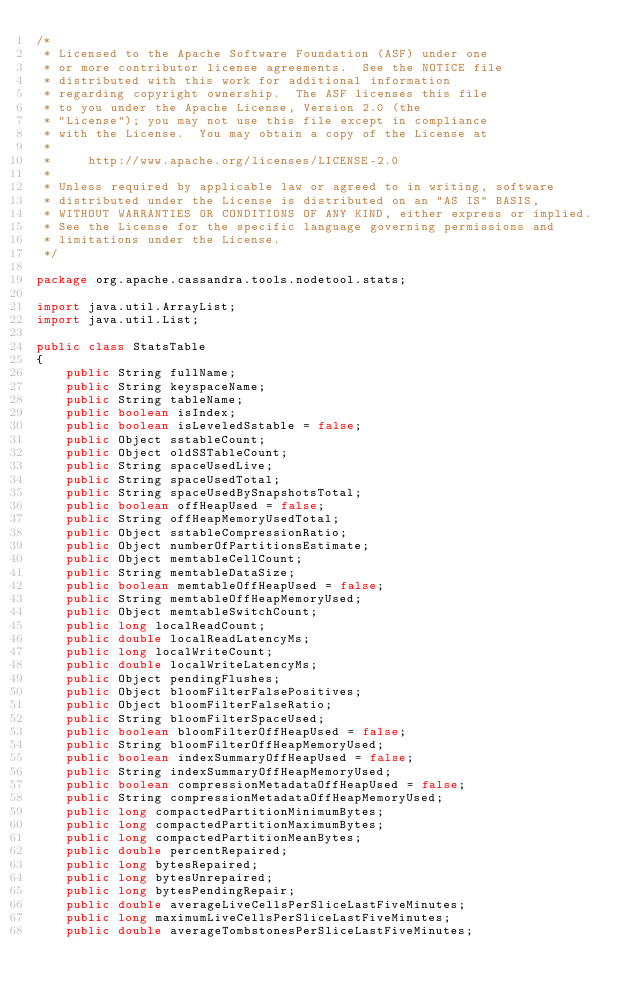<code> <loc_0><loc_0><loc_500><loc_500><_Java_>/*
 * Licensed to the Apache Software Foundation (ASF) under one
 * or more contributor license agreements.  See the NOTICE file
 * distributed with this work for additional information
 * regarding copyright ownership.  The ASF licenses this file
 * to you under the Apache License, Version 2.0 (the
 * "License"); you may not use this file except in compliance
 * with the License.  You may obtain a copy of the License at
 *
 *     http://www.apache.org/licenses/LICENSE-2.0
 *
 * Unless required by applicable law or agreed to in writing, software
 * distributed under the License is distributed on an "AS IS" BASIS,
 * WITHOUT WARRANTIES OR CONDITIONS OF ANY KIND, either express or implied.
 * See the License for the specific language governing permissions and
 * limitations under the License.
 */

package org.apache.cassandra.tools.nodetool.stats;

import java.util.ArrayList;
import java.util.List;

public class StatsTable
{
    public String fullName;
    public String keyspaceName;
    public String tableName;
    public boolean isIndex;
    public boolean isLeveledSstable = false;
    public Object sstableCount;
    public Object oldSSTableCount;
    public String spaceUsedLive;
    public String spaceUsedTotal;
    public String spaceUsedBySnapshotsTotal;
    public boolean offHeapUsed = false;
    public String offHeapMemoryUsedTotal;
    public Object sstableCompressionRatio;
    public Object numberOfPartitionsEstimate;
    public Object memtableCellCount;
    public String memtableDataSize;
    public boolean memtableOffHeapUsed = false;
    public String memtableOffHeapMemoryUsed;
    public Object memtableSwitchCount;
    public long localReadCount;
    public double localReadLatencyMs;
    public long localWriteCount;
    public double localWriteLatencyMs;
    public Object pendingFlushes;
    public Object bloomFilterFalsePositives;
    public Object bloomFilterFalseRatio;
    public String bloomFilterSpaceUsed;
    public boolean bloomFilterOffHeapUsed = false;
    public String bloomFilterOffHeapMemoryUsed;
    public boolean indexSummaryOffHeapUsed = false;
    public String indexSummaryOffHeapMemoryUsed;
    public boolean compressionMetadataOffHeapUsed = false;
    public String compressionMetadataOffHeapMemoryUsed;
    public long compactedPartitionMinimumBytes;
    public long compactedPartitionMaximumBytes;
    public long compactedPartitionMeanBytes;
    public double percentRepaired;
    public long bytesRepaired;
    public long bytesUnrepaired;
    public long bytesPendingRepair;
    public double averageLiveCellsPerSliceLastFiveMinutes;
    public long maximumLiveCellsPerSliceLastFiveMinutes;
    public double averageTombstonesPerSliceLastFiveMinutes;</code> 